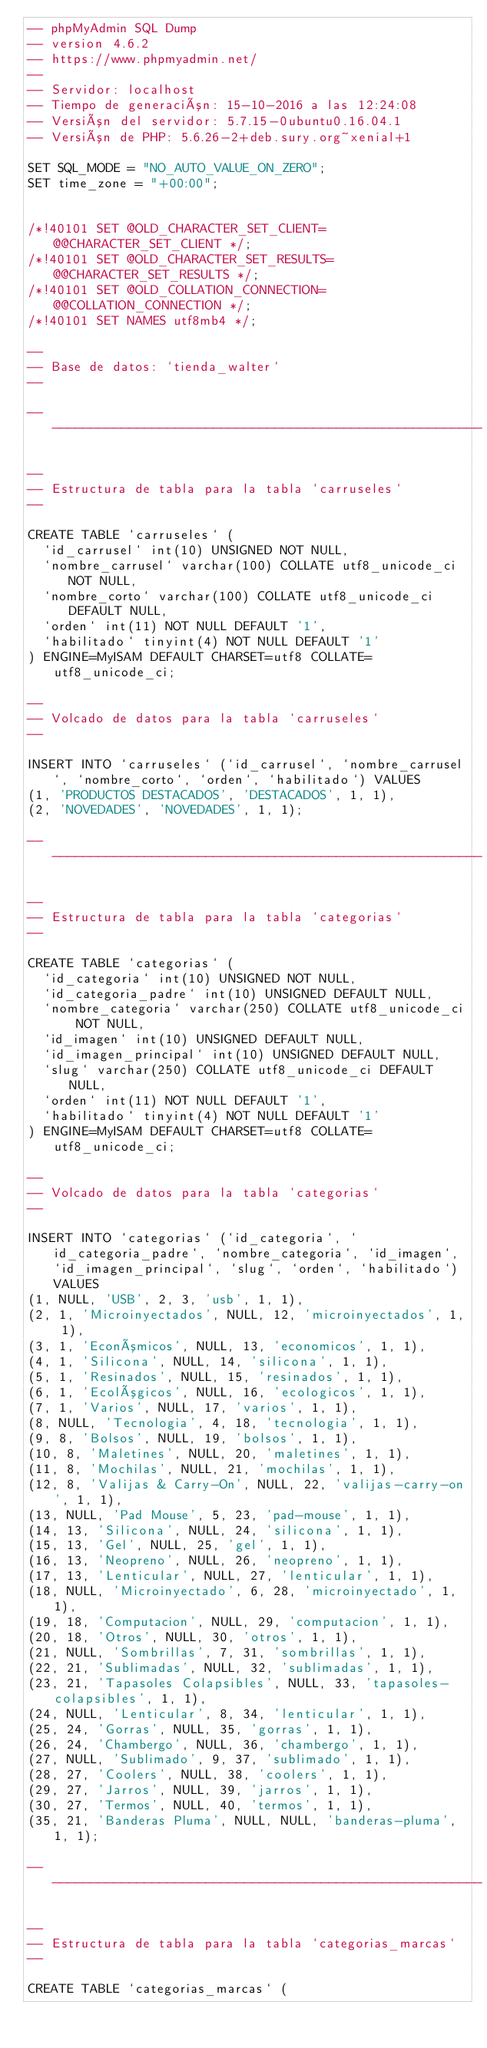<code> <loc_0><loc_0><loc_500><loc_500><_SQL_>-- phpMyAdmin SQL Dump
-- version 4.6.2
-- https://www.phpmyadmin.net/
--
-- Servidor: localhost
-- Tiempo de generación: 15-10-2016 a las 12:24:08
-- Versión del servidor: 5.7.15-0ubuntu0.16.04.1
-- Versión de PHP: 5.6.26-2+deb.sury.org~xenial+1

SET SQL_MODE = "NO_AUTO_VALUE_ON_ZERO";
SET time_zone = "+00:00";


/*!40101 SET @OLD_CHARACTER_SET_CLIENT=@@CHARACTER_SET_CLIENT */;
/*!40101 SET @OLD_CHARACTER_SET_RESULTS=@@CHARACTER_SET_RESULTS */;
/*!40101 SET @OLD_COLLATION_CONNECTION=@@COLLATION_CONNECTION */;
/*!40101 SET NAMES utf8mb4 */;

--
-- Base de datos: `tienda_walter`
--

-- --------------------------------------------------------

--
-- Estructura de tabla para la tabla `carruseles`
--

CREATE TABLE `carruseles` (
  `id_carrusel` int(10) UNSIGNED NOT NULL,
  `nombre_carrusel` varchar(100) COLLATE utf8_unicode_ci NOT NULL,
  `nombre_corto` varchar(100) COLLATE utf8_unicode_ci DEFAULT NULL,
  `orden` int(11) NOT NULL DEFAULT '1',
  `habilitado` tinyint(4) NOT NULL DEFAULT '1'
) ENGINE=MyISAM DEFAULT CHARSET=utf8 COLLATE=utf8_unicode_ci;

--
-- Volcado de datos para la tabla `carruseles`
--

INSERT INTO `carruseles` (`id_carrusel`, `nombre_carrusel`, `nombre_corto`, `orden`, `habilitado`) VALUES
(1, 'PRODUCTOS DESTACADOS', 'DESTACADOS', 1, 1),
(2, 'NOVEDADES', 'NOVEDADES', 1, 1);

-- --------------------------------------------------------

--
-- Estructura de tabla para la tabla `categorias`
--

CREATE TABLE `categorias` (
  `id_categoria` int(10) UNSIGNED NOT NULL,
  `id_categoria_padre` int(10) UNSIGNED DEFAULT NULL,
  `nombre_categoria` varchar(250) COLLATE utf8_unicode_ci NOT NULL,
  `id_imagen` int(10) UNSIGNED DEFAULT NULL,
  `id_imagen_principal` int(10) UNSIGNED DEFAULT NULL,
  `slug` varchar(250) COLLATE utf8_unicode_ci DEFAULT NULL,
  `orden` int(11) NOT NULL DEFAULT '1',
  `habilitado` tinyint(4) NOT NULL DEFAULT '1'
) ENGINE=MyISAM DEFAULT CHARSET=utf8 COLLATE=utf8_unicode_ci;

--
-- Volcado de datos para la tabla `categorias`
--

INSERT INTO `categorias` (`id_categoria`, `id_categoria_padre`, `nombre_categoria`, `id_imagen`, `id_imagen_principal`, `slug`, `orden`, `habilitado`) VALUES
(1, NULL, 'USB', 2, 3, 'usb', 1, 1),
(2, 1, 'Microinyectados', NULL, 12, 'microinyectados', 1, 1),
(3, 1, 'Económicos', NULL, 13, 'economicos', 1, 1),
(4, 1, 'Silicona', NULL, 14, 'silicona', 1, 1),
(5, 1, 'Resinados', NULL, 15, 'resinados', 1, 1),
(6, 1, 'Ecológicos', NULL, 16, 'ecologicos', 1, 1),
(7, 1, 'Varios', NULL, 17, 'varios', 1, 1),
(8, NULL, 'Tecnologia', 4, 18, 'tecnologia', 1, 1),
(9, 8, 'Bolsos', NULL, 19, 'bolsos', 1, 1),
(10, 8, 'Maletines', NULL, 20, 'maletines', 1, 1),
(11, 8, 'Mochilas', NULL, 21, 'mochilas', 1, 1),
(12, 8, 'Valijas & Carry-On', NULL, 22, 'valijas-carry-on', 1, 1),
(13, NULL, 'Pad Mouse', 5, 23, 'pad-mouse', 1, 1),
(14, 13, 'Silicona', NULL, 24, 'silicona', 1, 1),
(15, 13, 'Gel', NULL, 25, 'gel', 1, 1),
(16, 13, 'Neopreno', NULL, 26, 'neopreno', 1, 1),
(17, 13, 'Lenticular', NULL, 27, 'lenticular', 1, 1),
(18, NULL, 'Microinyectado', 6, 28, 'microinyectado', 1, 1),
(19, 18, 'Computacion', NULL, 29, 'computacion', 1, 1),
(20, 18, 'Otros', NULL, 30, 'otros', 1, 1),
(21, NULL, 'Sombrillas', 7, 31, 'sombrillas', 1, 1),
(22, 21, 'Sublimadas', NULL, 32, 'sublimadas', 1, 1),
(23, 21, 'Tapasoles Colapsibles', NULL, 33, 'tapasoles-colapsibles', 1, 1),
(24, NULL, 'Lenticular', 8, 34, 'lenticular', 1, 1),
(25, 24, 'Gorras', NULL, 35, 'gorras', 1, 1),
(26, 24, 'Chambergo', NULL, 36, 'chambergo', 1, 1),
(27, NULL, 'Sublimado', 9, 37, 'sublimado', 1, 1),
(28, 27, 'Coolers', NULL, 38, 'coolers', 1, 1),
(29, 27, 'Jarros', NULL, 39, 'jarros', 1, 1),
(30, 27, 'Termos', NULL, 40, 'termos', 1, 1),
(35, 21, 'Banderas Pluma', NULL, NULL, 'banderas-pluma', 1, 1);

-- --------------------------------------------------------

--
-- Estructura de tabla para la tabla `categorias_marcas`
--

CREATE TABLE `categorias_marcas` (</code> 